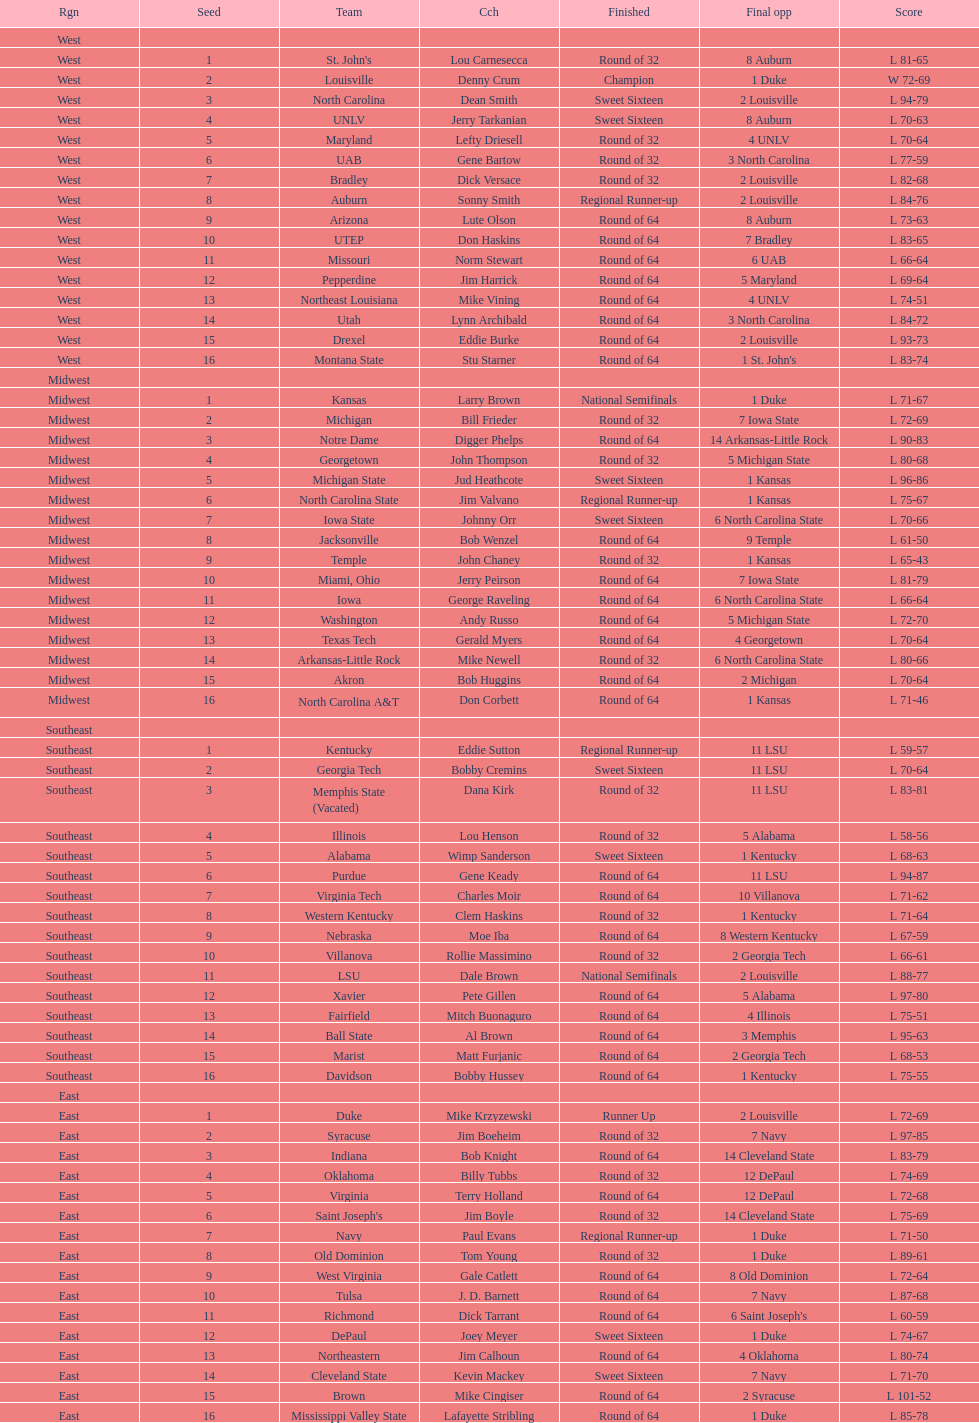How many 1 seeds are there? 4. Give me the full table as a dictionary. {'header': ['Rgn', 'Seed', 'Team', 'Cch', 'Finished', 'Final opp', 'Score'], 'rows': [['West', '', '', '', '', '', ''], ['West', '1', "St. John's", 'Lou Carnesecca', 'Round of 32', '8 Auburn', 'L 81-65'], ['West', '2', 'Louisville', 'Denny Crum', 'Champion', '1 Duke', 'W 72-69'], ['West', '3', 'North Carolina', 'Dean Smith', 'Sweet Sixteen', '2 Louisville', 'L 94-79'], ['West', '4', 'UNLV', 'Jerry Tarkanian', 'Sweet Sixteen', '8 Auburn', 'L 70-63'], ['West', '5', 'Maryland', 'Lefty Driesell', 'Round of 32', '4 UNLV', 'L 70-64'], ['West', '6', 'UAB', 'Gene Bartow', 'Round of 32', '3 North Carolina', 'L 77-59'], ['West', '7', 'Bradley', 'Dick Versace', 'Round of 32', '2 Louisville', 'L 82-68'], ['West', '8', 'Auburn', 'Sonny Smith', 'Regional Runner-up', '2 Louisville', 'L 84-76'], ['West', '9', 'Arizona', 'Lute Olson', 'Round of 64', '8 Auburn', 'L 73-63'], ['West', '10', 'UTEP', 'Don Haskins', 'Round of 64', '7 Bradley', 'L 83-65'], ['West', '11', 'Missouri', 'Norm Stewart', 'Round of 64', '6 UAB', 'L 66-64'], ['West', '12', 'Pepperdine', 'Jim Harrick', 'Round of 64', '5 Maryland', 'L 69-64'], ['West', '13', 'Northeast Louisiana', 'Mike Vining', 'Round of 64', '4 UNLV', 'L 74-51'], ['West', '14', 'Utah', 'Lynn Archibald', 'Round of 64', '3 North Carolina', 'L 84-72'], ['West', '15', 'Drexel', 'Eddie Burke', 'Round of 64', '2 Louisville', 'L 93-73'], ['West', '16', 'Montana State', 'Stu Starner', 'Round of 64', "1 St. John's", 'L 83-74'], ['Midwest', '', '', '', '', '', ''], ['Midwest', '1', 'Kansas', 'Larry Brown', 'National Semifinals', '1 Duke', 'L 71-67'], ['Midwest', '2', 'Michigan', 'Bill Frieder', 'Round of 32', '7 Iowa State', 'L 72-69'], ['Midwest', '3', 'Notre Dame', 'Digger Phelps', 'Round of 64', '14 Arkansas-Little Rock', 'L 90-83'], ['Midwest', '4', 'Georgetown', 'John Thompson', 'Round of 32', '5 Michigan State', 'L 80-68'], ['Midwest', '5', 'Michigan State', 'Jud Heathcote', 'Sweet Sixteen', '1 Kansas', 'L 96-86'], ['Midwest', '6', 'North Carolina State', 'Jim Valvano', 'Regional Runner-up', '1 Kansas', 'L 75-67'], ['Midwest', '7', 'Iowa State', 'Johnny Orr', 'Sweet Sixteen', '6 North Carolina State', 'L 70-66'], ['Midwest', '8', 'Jacksonville', 'Bob Wenzel', 'Round of 64', '9 Temple', 'L 61-50'], ['Midwest', '9', 'Temple', 'John Chaney', 'Round of 32', '1 Kansas', 'L 65-43'], ['Midwest', '10', 'Miami, Ohio', 'Jerry Peirson', 'Round of 64', '7 Iowa State', 'L 81-79'], ['Midwest', '11', 'Iowa', 'George Raveling', 'Round of 64', '6 North Carolina State', 'L 66-64'], ['Midwest', '12', 'Washington', 'Andy Russo', 'Round of 64', '5 Michigan State', 'L 72-70'], ['Midwest', '13', 'Texas Tech', 'Gerald Myers', 'Round of 64', '4 Georgetown', 'L 70-64'], ['Midwest', '14', 'Arkansas-Little Rock', 'Mike Newell', 'Round of 32', '6 North Carolina State', 'L 80-66'], ['Midwest', '15', 'Akron', 'Bob Huggins', 'Round of 64', '2 Michigan', 'L 70-64'], ['Midwest', '16', 'North Carolina A&T', 'Don Corbett', 'Round of 64', '1 Kansas', 'L 71-46'], ['Southeast', '', '', '', '', '', ''], ['Southeast', '1', 'Kentucky', 'Eddie Sutton', 'Regional Runner-up', '11 LSU', 'L 59-57'], ['Southeast', '2', 'Georgia Tech', 'Bobby Cremins', 'Sweet Sixteen', '11 LSU', 'L 70-64'], ['Southeast', '3', 'Memphis State (Vacated)', 'Dana Kirk', 'Round of 32', '11 LSU', 'L 83-81'], ['Southeast', '4', 'Illinois', 'Lou Henson', 'Round of 32', '5 Alabama', 'L 58-56'], ['Southeast', '5', 'Alabama', 'Wimp Sanderson', 'Sweet Sixteen', '1 Kentucky', 'L 68-63'], ['Southeast', '6', 'Purdue', 'Gene Keady', 'Round of 64', '11 LSU', 'L 94-87'], ['Southeast', '7', 'Virginia Tech', 'Charles Moir', 'Round of 64', '10 Villanova', 'L 71-62'], ['Southeast', '8', 'Western Kentucky', 'Clem Haskins', 'Round of 32', '1 Kentucky', 'L 71-64'], ['Southeast', '9', 'Nebraska', 'Moe Iba', 'Round of 64', '8 Western Kentucky', 'L 67-59'], ['Southeast', '10', 'Villanova', 'Rollie Massimino', 'Round of 32', '2 Georgia Tech', 'L 66-61'], ['Southeast', '11', 'LSU', 'Dale Brown', 'National Semifinals', '2 Louisville', 'L 88-77'], ['Southeast', '12', 'Xavier', 'Pete Gillen', 'Round of 64', '5 Alabama', 'L 97-80'], ['Southeast', '13', 'Fairfield', 'Mitch Buonaguro', 'Round of 64', '4 Illinois', 'L 75-51'], ['Southeast', '14', 'Ball State', 'Al Brown', 'Round of 64', '3 Memphis', 'L 95-63'], ['Southeast', '15', 'Marist', 'Matt Furjanic', 'Round of 64', '2 Georgia Tech', 'L 68-53'], ['Southeast', '16', 'Davidson', 'Bobby Hussey', 'Round of 64', '1 Kentucky', 'L 75-55'], ['East', '', '', '', '', '', ''], ['East', '1', 'Duke', 'Mike Krzyzewski', 'Runner Up', '2 Louisville', 'L 72-69'], ['East', '2', 'Syracuse', 'Jim Boeheim', 'Round of 32', '7 Navy', 'L 97-85'], ['East', '3', 'Indiana', 'Bob Knight', 'Round of 64', '14 Cleveland State', 'L 83-79'], ['East', '4', 'Oklahoma', 'Billy Tubbs', 'Round of 32', '12 DePaul', 'L 74-69'], ['East', '5', 'Virginia', 'Terry Holland', 'Round of 64', '12 DePaul', 'L 72-68'], ['East', '6', "Saint Joseph's", 'Jim Boyle', 'Round of 32', '14 Cleveland State', 'L 75-69'], ['East', '7', 'Navy', 'Paul Evans', 'Regional Runner-up', '1 Duke', 'L 71-50'], ['East', '8', 'Old Dominion', 'Tom Young', 'Round of 32', '1 Duke', 'L 89-61'], ['East', '9', 'West Virginia', 'Gale Catlett', 'Round of 64', '8 Old Dominion', 'L 72-64'], ['East', '10', 'Tulsa', 'J. D. Barnett', 'Round of 64', '7 Navy', 'L 87-68'], ['East', '11', 'Richmond', 'Dick Tarrant', 'Round of 64', "6 Saint Joseph's", 'L 60-59'], ['East', '12', 'DePaul', 'Joey Meyer', 'Sweet Sixteen', '1 Duke', 'L 74-67'], ['East', '13', 'Northeastern', 'Jim Calhoun', 'Round of 64', '4 Oklahoma', 'L 80-74'], ['East', '14', 'Cleveland State', 'Kevin Mackey', 'Sweet Sixteen', '7 Navy', 'L 71-70'], ['East', '15', 'Brown', 'Mike Cingiser', 'Round of 64', '2 Syracuse', 'L 101-52'], ['East', '16', 'Mississippi Valley State', 'Lafayette Stribling', 'Round of 64', '1 Duke', 'L 85-78']]} 